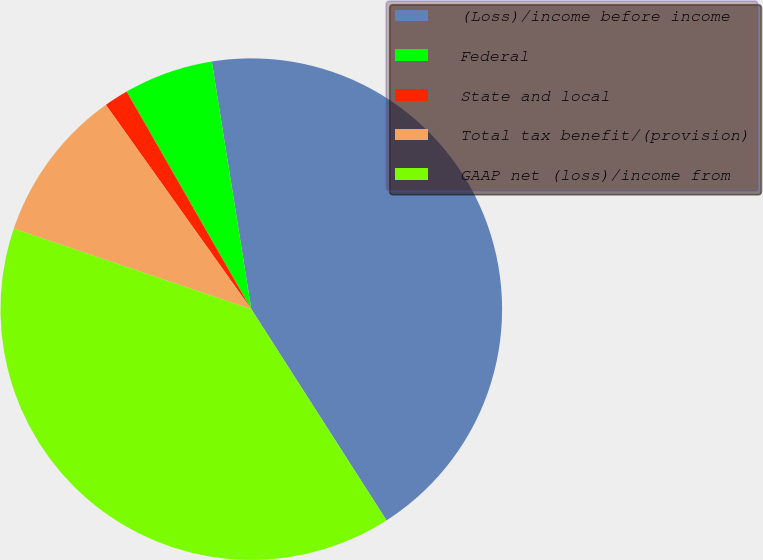Convert chart to OTSL. <chart><loc_0><loc_0><loc_500><loc_500><pie_chart><fcel>(Loss)/income before income<fcel>Federal<fcel>State and local<fcel>Total tax benefit/(provision)<fcel>GAAP net (loss)/income from<nl><fcel>43.45%<fcel>5.76%<fcel>1.57%<fcel>9.95%<fcel>39.26%<nl></chart> 